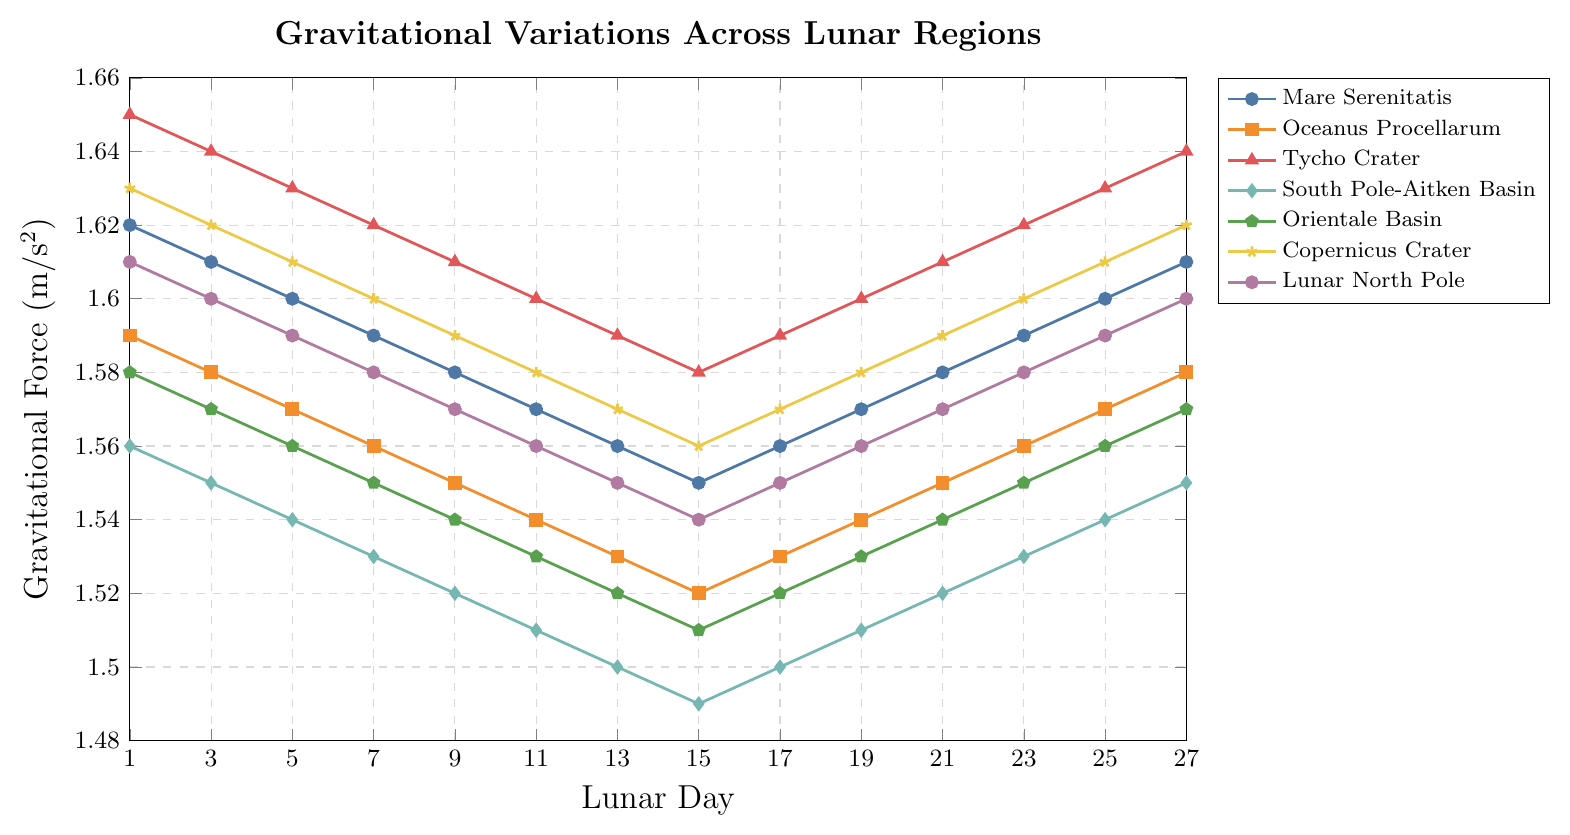What's the average gravitational force measured at Mare Serenitatis over the lunar days? Sum the gravitational forces at Mare Serenitatis across all given lunar days (1.62 + 1.61 + 1.60 + 1.59 + 1.58 + 1.57 + 1.56 + 1.55 + 1.56 + 1.57 + 1.58 + 1.59 + 1.60 + 1.61) = 21.69. Divide by the number of days (14). 21.69 / 14 = 1.55
Answer: 1.55 Which region shows the highest gravitational force on Day 1? Look at the gravitational force values of all regions on Day 1. Tycho Crater has the highest value (1.65).
Answer: Tycho Crater Between which lunar days does the gravitational force remain constant in Copernicus Crater? Examine the trend in the Copernicus Crater line. The gravitational force changes between each set of days, so there is no segment where it remains constant.
Answer: None How does the gravitational force trend in Lunar North Pole change from Day 1 to Day 15? The values decrease from Day 1 (1.61) to Day 15 (1.54).
Answer: Decreases What is the combined gravitational force of all regions on Day 7? Sum the gravitational forces at all regions on Day 7: (1.59 + 1.56 + 1.62 + 1.53 + 1.55 + 1.60 + 1.58) = 11.03
Answer: 11.03 Which region's gravitational force increases the most from Day 15 to Day 17? Compute the difference for each region: 
Mare Serenitatis: 1.56 - 1.55 = 0.01,
Oceanus Procellarum: 1.53 - 1.52 = 0.01,
Tycho Crater: 1.59 - 1.58 = 0.01,
South Pole-Aitken Basin: 1.50 - 1.49 = 0.01,
Orientale Basin: 1.52 - 1.51 = 0.01,
Copernicus Crater: 1.57 - 1.56 = 0.01,
Lunar North Pole: 1.55 - 1.54 = 0.01.
All regions have an equal increase.
Answer: All equal Compare the gravitational force ranges (maximum - minimum) between Mare Serenitatis and South Pole-Aitken Basin. Which has a larger range? For Mare Serenitatis: Max = 1.62, Min = 1.55, Range = 1.62 - 1.55 = 0.07. For South Pole-Aitken Basin: Max = 1.56, Min = 1.49, Range = 1.56 - 1.49 = 0.07. Both have the same range.
Answer: Equal On which lunar day do at least two regions have the same gravitational force? Day 19, where both Mare Serenitatis and Tycho Crater have a gravitational force of 1.57.
Answer: Day 19 Does any region's gravitational force return to its initial value by Day 27? Compare Day 1 and Day 27 values for all regions. None of the regions return to their initial value.
Answer: None Which regions show a repeating pattern in their gravitational force? None of the given regions show an exact repeating pattern in the data provided.
Answer: None 